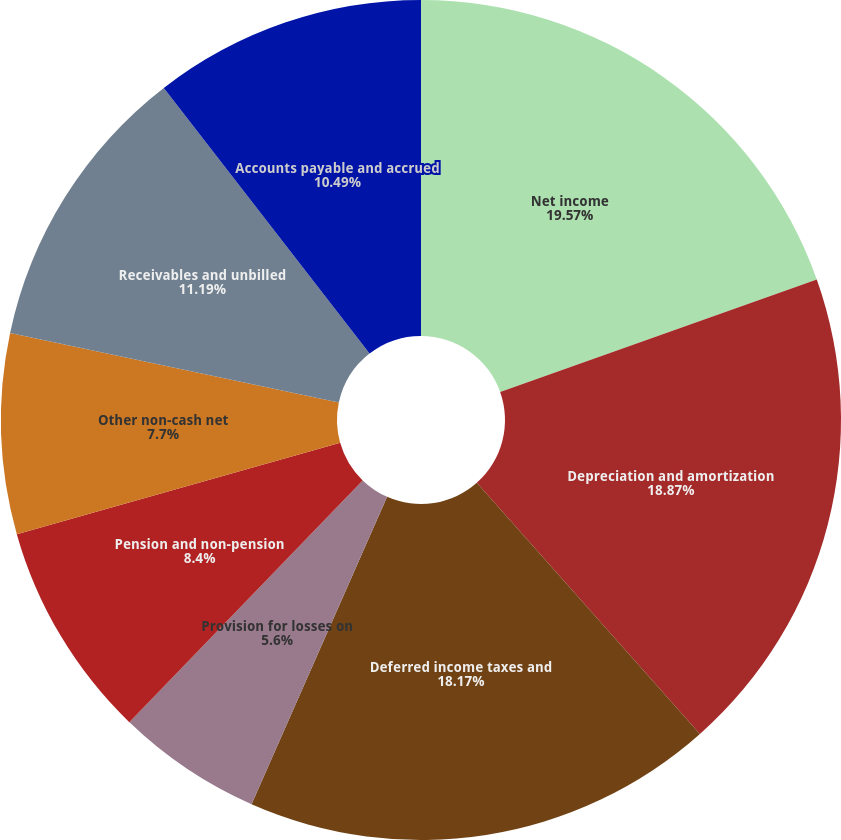Convert chart to OTSL. <chart><loc_0><loc_0><loc_500><loc_500><pie_chart><fcel>Net income<fcel>Depreciation and amortization<fcel>Deferred income taxes and<fcel>Provision for losses on<fcel>Gain on asset dispositions and<fcel>Pension and non-pension<fcel>Other non-cash net<fcel>Receivables and unbilled<fcel>Accounts payable and accrued<nl><fcel>19.57%<fcel>18.87%<fcel>18.17%<fcel>5.6%<fcel>0.01%<fcel>8.4%<fcel>7.7%<fcel>11.19%<fcel>10.49%<nl></chart> 